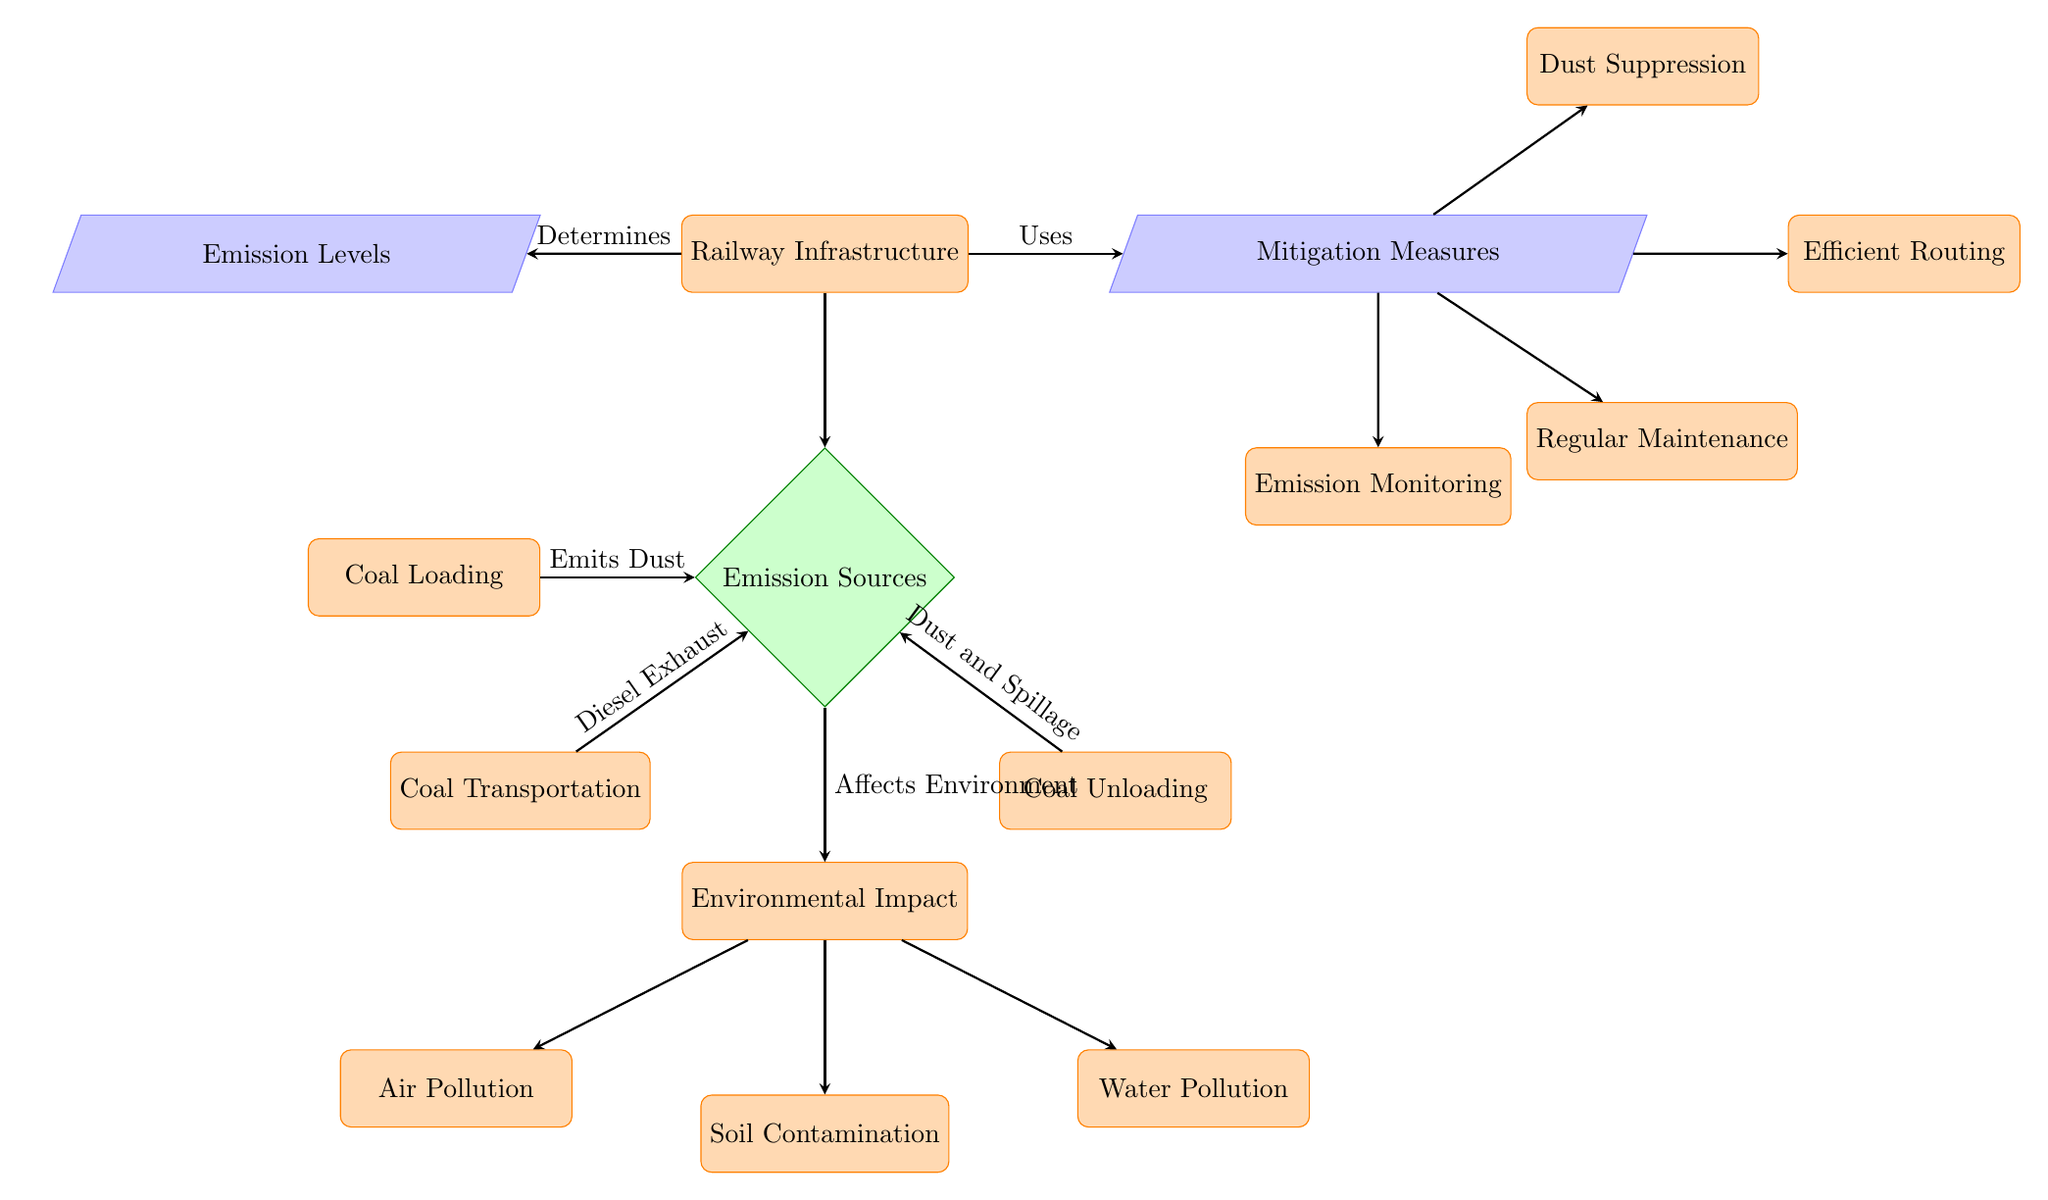What are the three processes that lead to emissions? The diagram indicates the three processes leading to emissions as "Coal Loading," "Coal Transportation," and "Coal Unloading," which are all depicted as processes connected to the "Emission Sources" decision node.
Answer: Coal Loading, Coal Transportation, Coal Unloading What type of pollution is linked to air in this diagram? According to the diagram, "Air Pollution" is shown as a direct impact of the emission sources, specifically stemming from the environmental impact connected to the emissions decision node.
Answer: Air Pollution How many emission mitigation measures are listed? The diagram lists four distinct mitigation measures: "Dust Suppression," "Efficient Routing," "Regular Maintenance," and "Emission Monitoring," all stemming from the "Mitigation Measures" node.
Answer: 4 Which process emits diesel exhaust? The diagram indicates that "Coal Transportation" emits "Diesel Exhaust," shown as an annotation between the "Coal Transportation" node and the "Emission Sources" decision node, suggesting a link between transportation and emissions.
Answer: Coal Transportation What is the relationship between 'Railway Infrastructure' and 'Emission Levels'? The diagram shows a direct relationship where "Railway Infrastructure" determines "Emission Levels," illustrated by an arrow pointing from the "Railway Infrastructure" process towards the "Emission Levels" data node.
Answer: Determines What is the outcome of emissions on the environment? The diagram indicates that emissions affect the environment, leading to the aggregate node labeled "Environmental Impact," which then branches out into specific pollution types: air, soil, and water.
Answer: Affects Environment What measure focuses on reducing dust during coal handling? The diagram identifies "Dust Suppression" as the specific measure aimed at reducing dust emissions, represented in the mitigation measures section of the diagram.
Answer: Dust Suppression Which node is classified as a decision type? "Emission Sources" is categorized as a decision node, evident in its diamond shape and its role in determining various emission outputs from the associated processes.
Answer: Emission Sources Which type of pollution is represented as a concern for both soil and water? The diagram connects "Soil Contamination" and "Water Pollution" as types of environmental impacts, highlighting these as concerns related to emissions from coal processes.
Answer: Soil Contamination, Water Pollution 